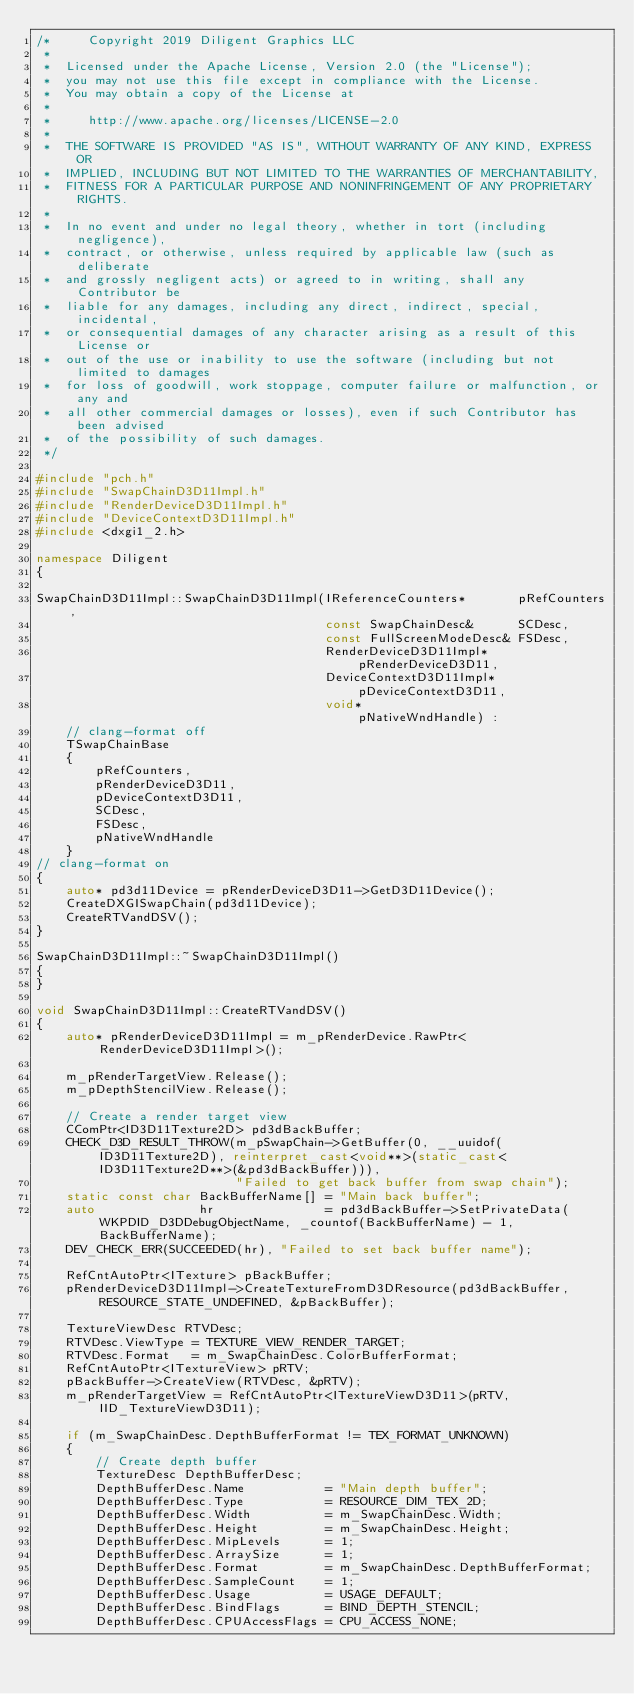<code> <loc_0><loc_0><loc_500><loc_500><_C++_>/*     Copyright 2019 Diligent Graphics LLC
 *  
 *  Licensed under the Apache License, Version 2.0 (the "License");
 *  you may not use this file except in compliance with the License.
 *  You may obtain a copy of the License at
 * 
 *     http://www.apache.org/licenses/LICENSE-2.0
 * 
 *  THE SOFTWARE IS PROVIDED "AS IS", WITHOUT WARRANTY OF ANY KIND, EXPRESS OR
 *  IMPLIED, INCLUDING BUT NOT LIMITED TO THE WARRANTIES OF MERCHANTABILITY,
 *  FITNESS FOR A PARTICULAR PURPOSE AND NONINFRINGEMENT OF ANY PROPRIETARY RIGHTS.
 *
 *  In no event and under no legal theory, whether in tort (including negligence), 
 *  contract, or otherwise, unless required by applicable law (such as deliberate 
 *  and grossly negligent acts) or agreed to in writing, shall any Contributor be
 *  liable for any damages, including any direct, indirect, special, incidental, 
 *  or consequential damages of any character arising as a result of this License or 
 *  out of the use or inability to use the software (including but not limited to damages 
 *  for loss of goodwill, work stoppage, computer failure or malfunction, or any and 
 *  all other commercial damages or losses), even if such Contributor has been advised 
 *  of the possibility of such damages.
 */

#include "pch.h"
#include "SwapChainD3D11Impl.h"
#include "RenderDeviceD3D11Impl.h"
#include "DeviceContextD3D11Impl.h"
#include <dxgi1_2.h>

namespace Diligent
{

SwapChainD3D11Impl::SwapChainD3D11Impl(IReferenceCounters*       pRefCounters,
                                       const SwapChainDesc&      SCDesc,
                                       const FullScreenModeDesc& FSDesc,
                                       RenderDeviceD3D11Impl*    pRenderDeviceD3D11,
                                       DeviceContextD3D11Impl*   pDeviceContextD3D11,
                                       void*                     pNativeWndHandle) :
    // clang-format off
    TSwapChainBase
    {
        pRefCounters,
        pRenderDeviceD3D11,
        pDeviceContextD3D11,
        SCDesc,
        FSDesc,
        pNativeWndHandle
    }
// clang-format on
{
    auto* pd3d11Device = pRenderDeviceD3D11->GetD3D11Device();
    CreateDXGISwapChain(pd3d11Device);
    CreateRTVandDSV();
}

SwapChainD3D11Impl::~SwapChainD3D11Impl()
{
}

void SwapChainD3D11Impl::CreateRTVandDSV()
{
    auto* pRenderDeviceD3D11Impl = m_pRenderDevice.RawPtr<RenderDeviceD3D11Impl>();

    m_pRenderTargetView.Release();
    m_pDepthStencilView.Release();

    // Create a render target view
    CComPtr<ID3D11Texture2D> pd3dBackBuffer;
    CHECK_D3D_RESULT_THROW(m_pSwapChain->GetBuffer(0, __uuidof(ID3D11Texture2D), reinterpret_cast<void**>(static_cast<ID3D11Texture2D**>(&pd3dBackBuffer))),
                           "Failed to get back buffer from swap chain");
    static const char BackBufferName[] = "Main back buffer";
    auto              hr               = pd3dBackBuffer->SetPrivateData(WKPDID_D3DDebugObjectName, _countof(BackBufferName) - 1, BackBufferName);
    DEV_CHECK_ERR(SUCCEEDED(hr), "Failed to set back buffer name");

    RefCntAutoPtr<ITexture> pBackBuffer;
    pRenderDeviceD3D11Impl->CreateTextureFromD3DResource(pd3dBackBuffer, RESOURCE_STATE_UNDEFINED, &pBackBuffer);

    TextureViewDesc RTVDesc;
    RTVDesc.ViewType = TEXTURE_VIEW_RENDER_TARGET;
    RTVDesc.Format   = m_SwapChainDesc.ColorBufferFormat;
    RefCntAutoPtr<ITextureView> pRTV;
    pBackBuffer->CreateView(RTVDesc, &pRTV);
    m_pRenderTargetView = RefCntAutoPtr<ITextureViewD3D11>(pRTV, IID_TextureViewD3D11);

    if (m_SwapChainDesc.DepthBufferFormat != TEX_FORMAT_UNKNOWN)
    {
        // Create depth buffer
        TextureDesc DepthBufferDesc;
        DepthBufferDesc.Name           = "Main depth buffer";
        DepthBufferDesc.Type           = RESOURCE_DIM_TEX_2D;
        DepthBufferDesc.Width          = m_SwapChainDesc.Width;
        DepthBufferDesc.Height         = m_SwapChainDesc.Height;
        DepthBufferDesc.MipLevels      = 1;
        DepthBufferDesc.ArraySize      = 1;
        DepthBufferDesc.Format         = m_SwapChainDesc.DepthBufferFormat;
        DepthBufferDesc.SampleCount    = 1;
        DepthBufferDesc.Usage          = USAGE_DEFAULT;
        DepthBufferDesc.BindFlags      = BIND_DEPTH_STENCIL;
        DepthBufferDesc.CPUAccessFlags = CPU_ACCESS_NONE;</code> 